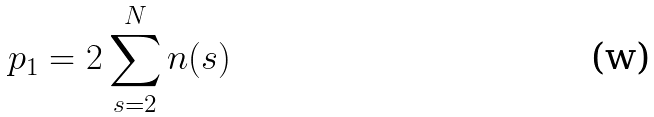<formula> <loc_0><loc_0><loc_500><loc_500>p _ { 1 } = 2 \sum _ { s = 2 } ^ { N } n ( s )</formula> 